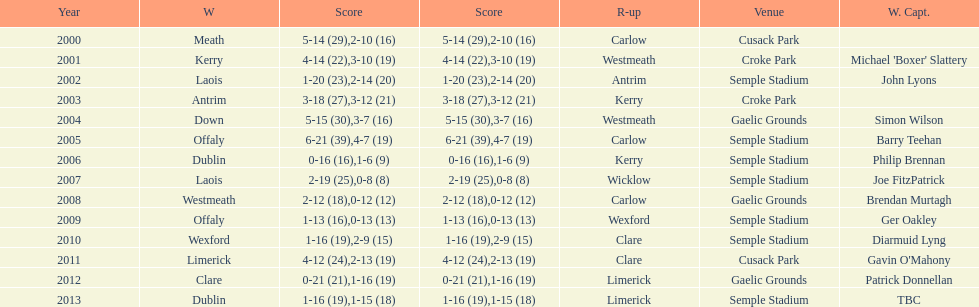What is the total number of times the competition was held at the semple stadium venue? 7. 